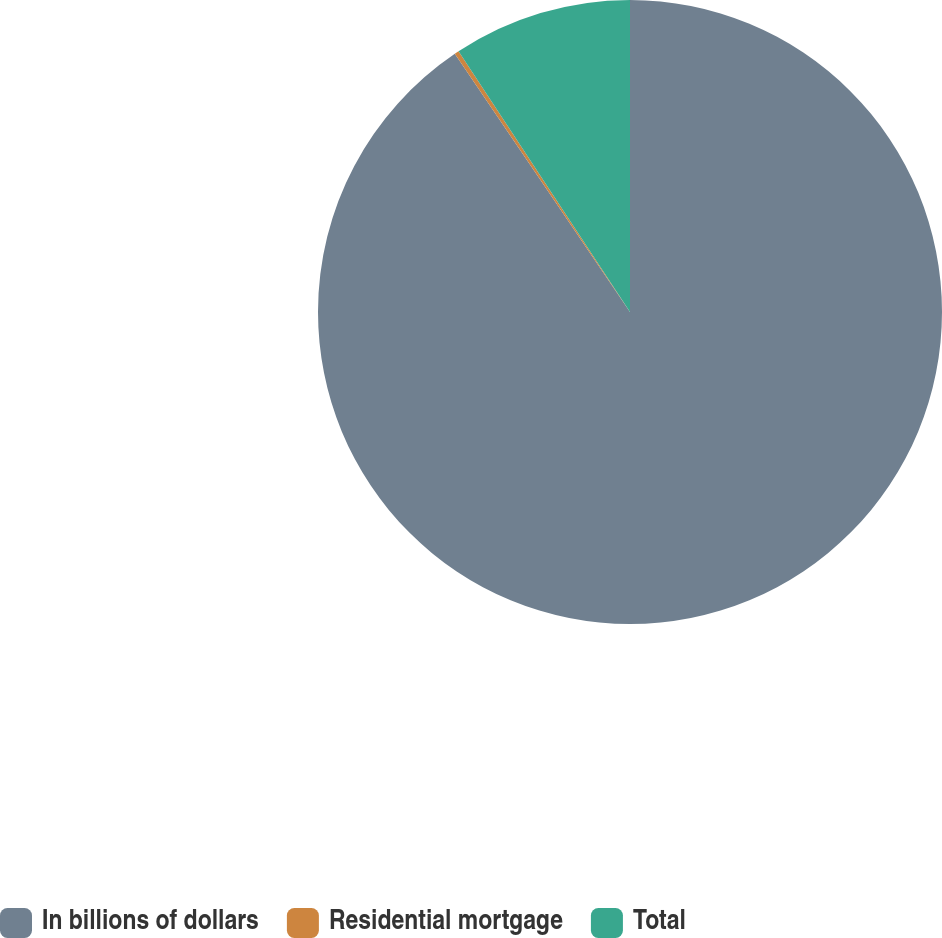<chart> <loc_0><loc_0><loc_500><loc_500><pie_chart><fcel>In billions of dollars<fcel>Residential mortgage<fcel>Total<nl><fcel>90.51%<fcel>0.23%<fcel>9.26%<nl></chart> 